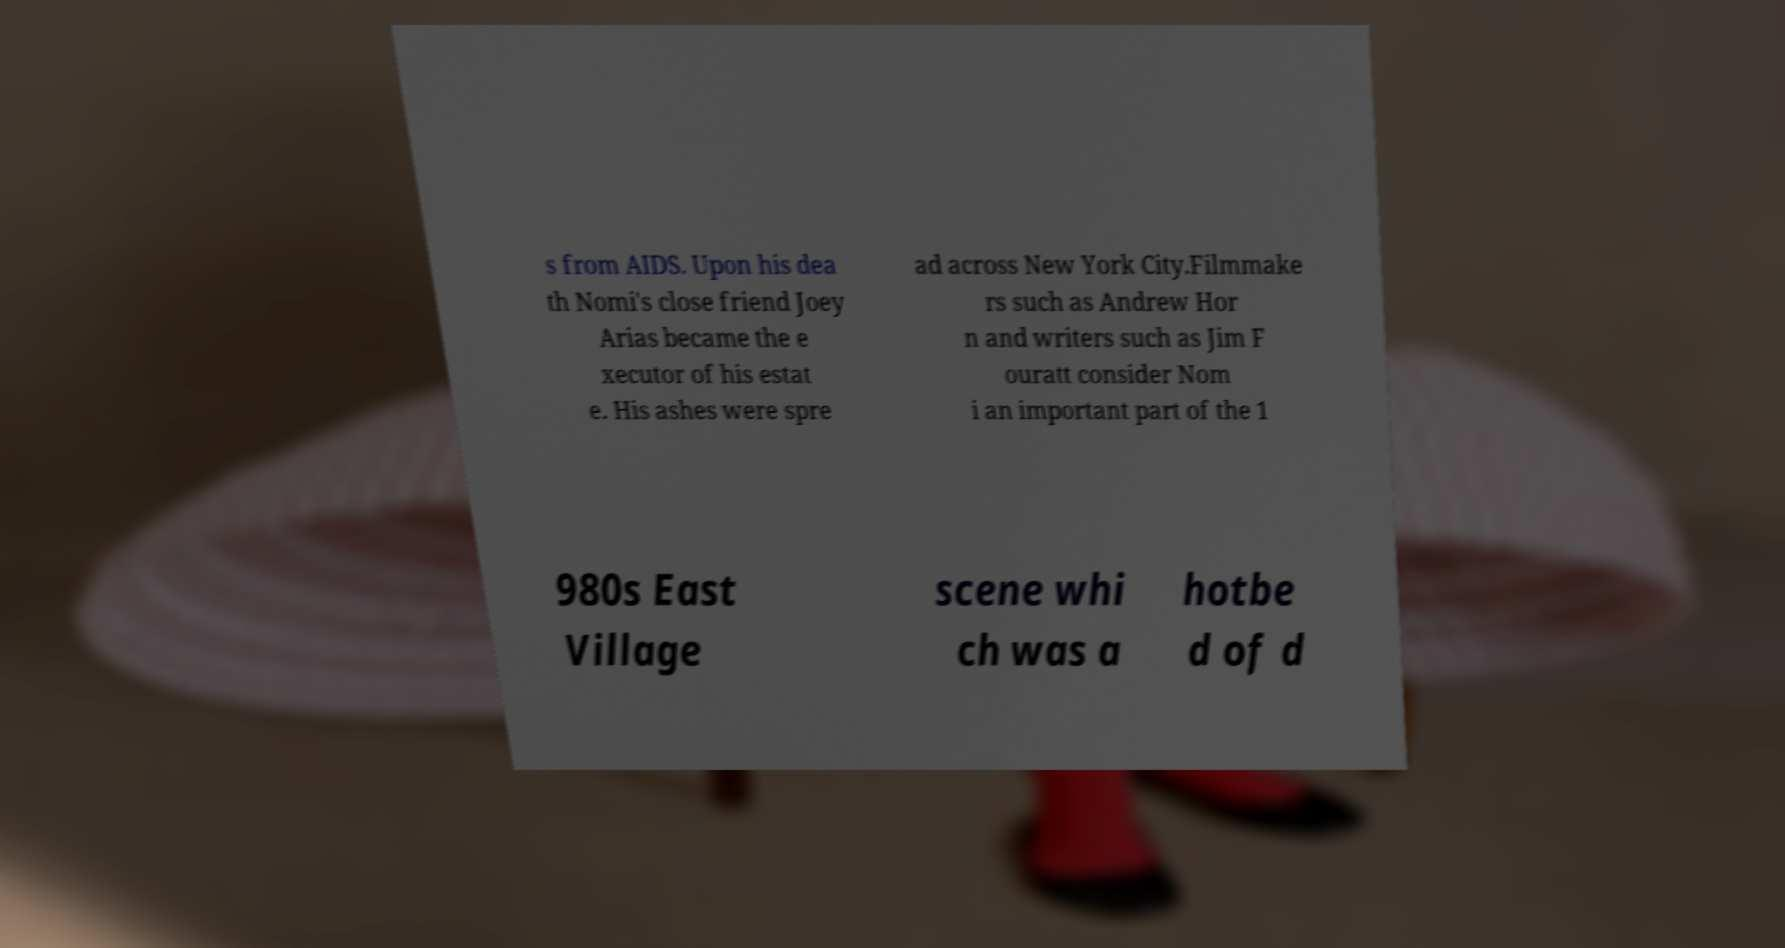Please identify and transcribe the text found in this image. s from AIDS. Upon his dea th Nomi's close friend Joey Arias became the e xecutor of his estat e. His ashes were spre ad across New York City.Filmmake rs such as Andrew Hor n and writers such as Jim F ouratt consider Nom i an important part of the 1 980s East Village scene whi ch was a hotbe d of d 